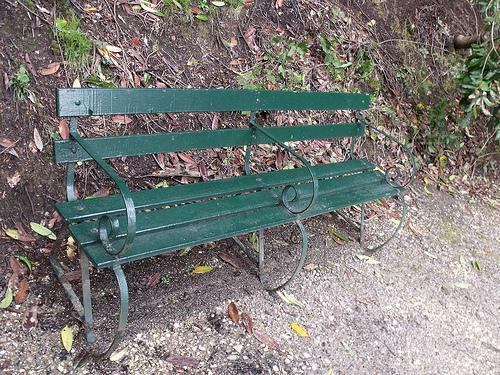How many benches near the hill?
Give a very brief answer. 1. How many legs the bench has?
Give a very brief answer. 3. 